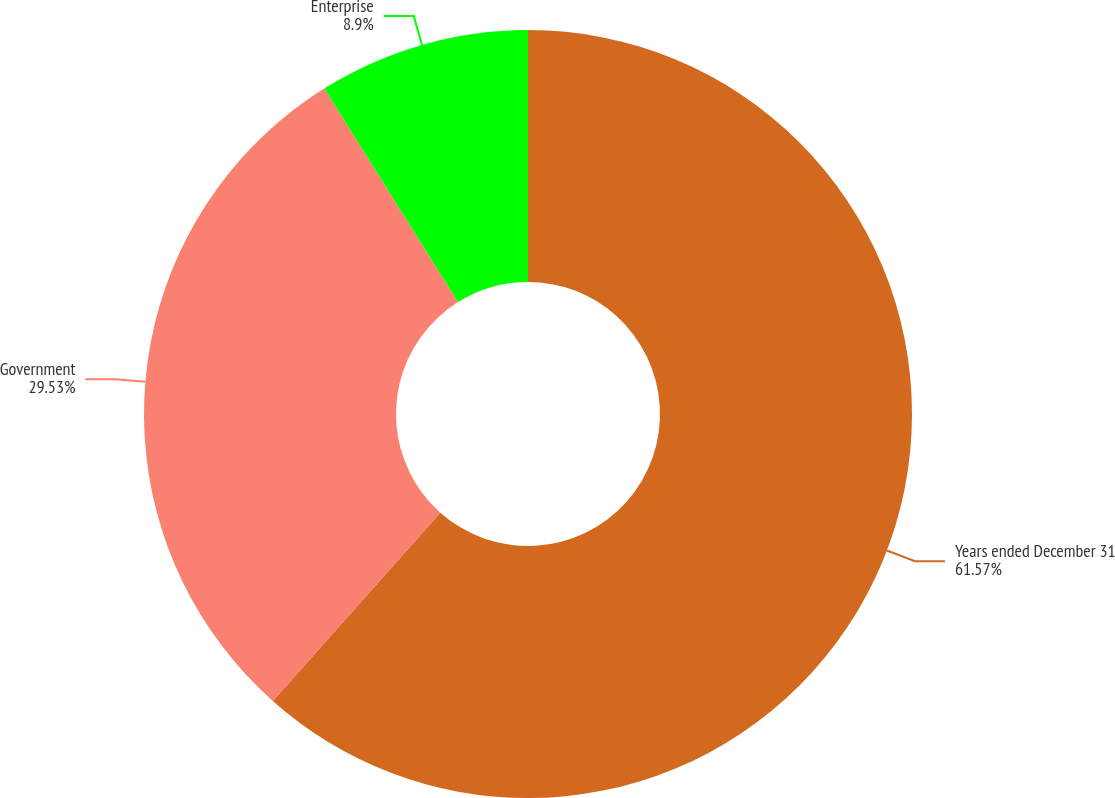Convert chart. <chart><loc_0><loc_0><loc_500><loc_500><pie_chart><fcel>Years ended December 31<fcel>Government<fcel>Enterprise<nl><fcel>61.57%<fcel>29.53%<fcel>8.9%<nl></chart> 